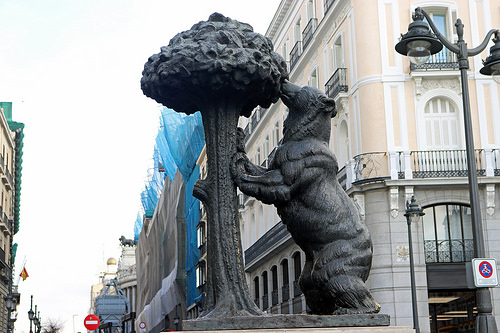<image>
Is there a sign behind the sign? Yes. From this viewpoint, the sign is positioned behind the sign, with the sign partially or fully occluding the sign. 